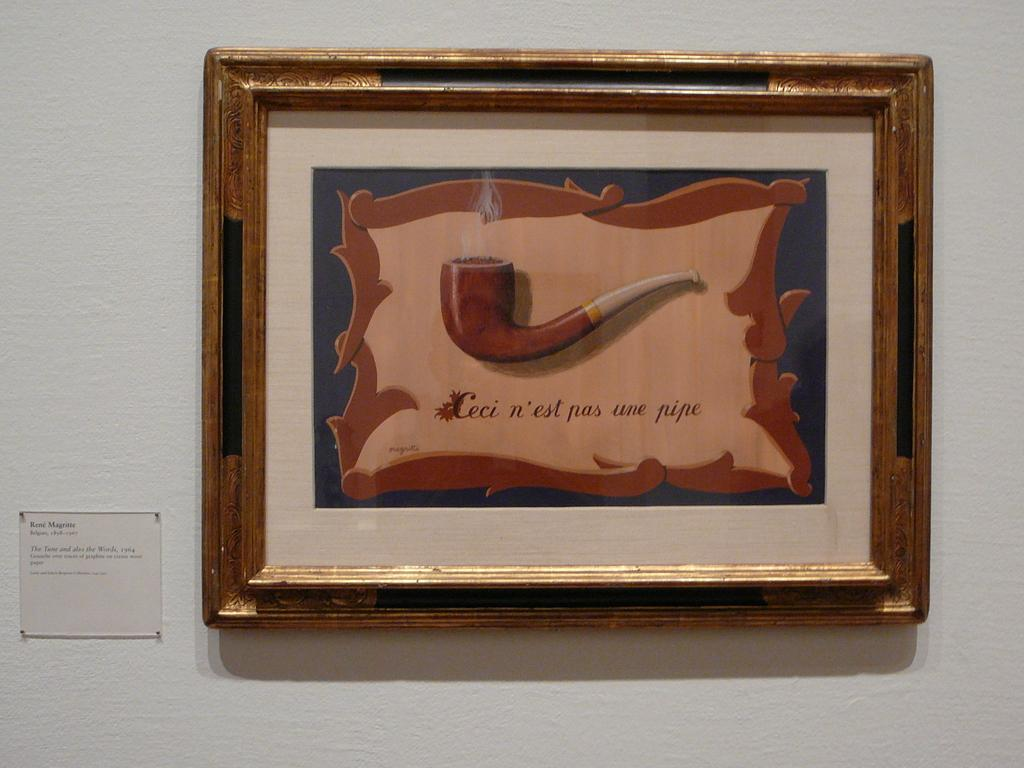Provide a one-sentence caption for the provided image. A framed painting of a pipe says "Ceci n'est pas une pipe". 